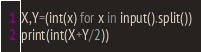Convert code to text. <code><loc_0><loc_0><loc_500><loc_500><_Python_>X,Y=(int(x) for x in input().split())
print(int(X+Y/2))</code> 